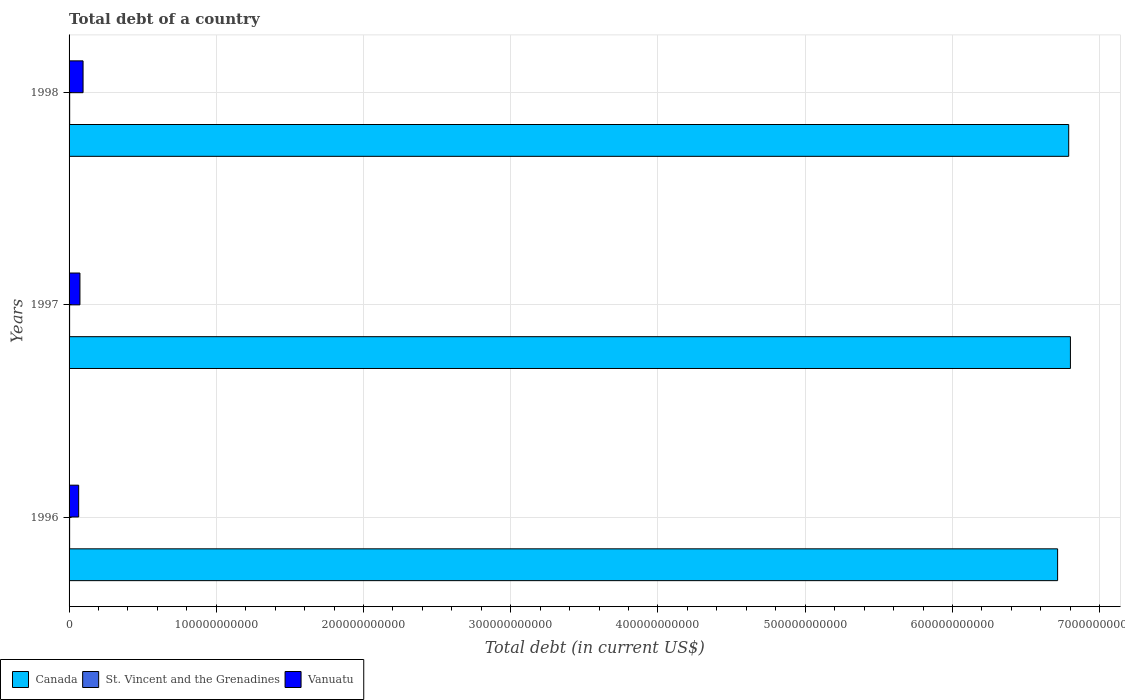How many different coloured bars are there?
Offer a very short reply. 3. How many groups of bars are there?
Offer a terse response. 3. Are the number of bars per tick equal to the number of legend labels?
Make the answer very short. Yes. What is the debt in Vanuatu in 1998?
Ensure brevity in your answer.  9.50e+09. Across all years, what is the maximum debt in Canada?
Give a very brief answer. 6.80e+11. Across all years, what is the minimum debt in Vanuatu?
Provide a short and direct response. 6.52e+09. In which year was the debt in Vanuatu maximum?
Offer a terse response. 1998. What is the total debt in St. Vincent and the Grenadines in the graph?
Keep it short and to the point. 1.15e+09. What is the difference between the debt in Canada in 1996 and that in 1997?
Make the answer very short. -8.71e+09. What is the difference between the debt in Canada in 1996 and the debt in St. Vincent and the Grenadines in 1998?
Offer a very short reply. 6.71e+11. What is the average debt in St. Vincent and the Grenadines per year?
Provide a succinct answer. 3.82e+08. In the year 1996, what is the difference between the debt in Vanuatu and debt in St. Vincent and the Grenadines?
Ensure brevity in your answer.  6.15e+09. In how many years, is the debt in St. Vincent and the Grenadines greater than 260000000000 US$?
Your answer should be very brief. 0. What is the ratio of the debt in Vanuatu in 1997 to that in 1998?
Your response must be concise. 0.78. Is the debt in Vanuatu in 1997 less than that in 1998?
Your response must be concise. Yes. Is the difference between the debt in Vanuatu in 1997 and 1998 greater than the difference between the debt in St. Vincent and the Grenadines in 1997 and 1998?
Provide a succinct answer. No. What is the difference between the highest and the second highest debt in Vanuatu?
Ensure brevity in your answer.  2.12e+09. What is the difference between the highest and the lowest debt in St. Vincent and the Grenadines?
Your answer should be very brief. 3.41e+07. What does the 2nd bar from the top in 1998 represents?
Provide a short and direct response. St. Vincent and the Grenadines. Is it the case that in every year, the sum of the debt in Canada and debt in Vanuatu is greater than the debt in St. Vincent and the Grenadines?
Your answer should be compact. Yes. How many bars are there?
Make the answer very short. 9. How many years are there in the graph?
Your answer should be compact. 3. What is the difference between two consecutive major ticks on the X-axis?
Offer a very short reply. 1.00e+11. Does the graph contain any zero values?
Your answer should be very brief. No. Does the graph contain grids?
Provide a succinct answer. Yes. Where does the legend appear in the graph?
Offer a very short reply. Bottom left. What is the title of the graph?
Your response must be concise. Total debt of a country. Does "Curacao" appear as one of the legend labels in the graph?
Make the answer very short. No. What is the label or title of the X-axis?
Offer a terse response. Total debt (in current US$). What is the label or title of the Y-axis?
Provide a short and direct response. Years. What is the Total debt (in current US$) in Canada in 1996?
Ensure brevity in your answer.  6.71e+11. What is the Total debt (in current US$) of St. Vincent and the Grenadines in 1996?
Provide a short and direct response. 3.72e+08. What is the Total debt (in current US$) of Vanuatu in 1996?
Your answer should be compact. 6.52e+09. What is the Total debt (in current US$) of Canada in 1997?
Offer a very short reply. 6.80e+11. What is the Total debt (in current US$) of St. Vincent and the Grenadines in 1997?
Give a very brief answer. 3.70e+08. What is the Total debt (in current US$) in Vanuatu in 1997?
Your response must be concise. 7.38e+09. What is the Total debt (in current US$) of Canada in 1998?
Keep it short and to the point. 6.79e+11. What is the Total debt (in current US$) of St. Vincent and the Grenadines in 1998?
Your answer should be very brief. 4.04e+08. What is the Total debt (in current US$) in Vanuatu in 1998?
Your answer should be very brief. 9.50e+09. Across all years, what is the maximum Total debt (in current US$) of Canada?
Give a very brief answer. 6.80e+11. Across all years, what is the maximum Total debt (in current US$) of St. Vincent and the Grenadines?
Your answer should be compact. 4.04e+08. Across all years, what is the maximum Total debt (in current US$) of Vanuatu?
Provide a succinct answer. 9.50e+09. Across all years, what is the minimum Total debt (in current US$) of Canada?
Keep it short and to the point. 6.71e+11. Across all years, what is the minimum Total debt (in current US$) in St. Vincent and the Grenadines?
Your answer should be compact. 3.70e+08. Across all years, what is the minimum Total debt (in current US$) in Vanuatu?
Provide a short and direct response. 6.52e+09. What is the total Total debt (in current US$) of Canada in the graph?
Offer a terse response. 2.03e+12. What is the total Total debt (in current US$) in St. Vincent and the Grenadines in the graph?
Your answer should be very brief. 1.15e+09. What is the total Total debt (in current US$) in Vanuatu in the graph?
Your answer should be compact. 2.34e+1. What is the difference between the Total debt (in current US$) in Canada in 1996 and that in 1997?
Your response must be concise. -8.71e+09. What is the difference between the Total debt (in current US$) of St. Vincent and the Grenadines in 1996 and that in 1997?
Make the answer very short. 2.60e+06. What is the difference between the Total debt (in current US$) of Vanuatu in 1996 and that in 1997?
Your answer should be very brief. -8.58e+08. What is the difference between the Total debt (in current US$) of Canada in 1996 and that in 1998?
Keep it short and to the point. -7.54e+09. What is the difference between the Total debt (in current US$) of St. Vincent and the Grenadines in 1996 and that in 1998?
Give a very brief answer. -3.15e+07. What is the difference between the Total debt (in current US$) of Vanuatu in 1996 and that in 1998?
Offer a very short reply. -2.98e+09. What is the difference between the Total debt (in current US$) in Canada in 1997 and that in 1998?
Your answer should be very brief. 1.16e+09. What is the difference between the Total debt (in current US$) in St. Vincent and the Grenadines in 1997 and that in 1998?
Keep it short and to the point. -3.41e+07. What is the difference between the Total debt (in current US$) of Vanuatu in 1997 and that in 1998?
Your answer should be very brief. -2.12e+09. What is the difference between the Total debt (in current US$) in Canada in 1996 and the Total debt (in current US$) in St. Vincent and the Grenadines in 1997?
Offer a very short reply. 6.71e+11. What is the difference between the Total debt (in current US$) in Canada in 1996 and the Total debt (in current US$) in Vanuatu in 1997?
Provide a succinct answer. 6.64e+11. What is the difference between the Total debt (in current US$) of St. Vincent and the Grenadines in 1996 and the Total debt (in current US$) of Vanuatu in 1997?
Your answer should be very brief. -7.01e+09. What is the difference between the Total debt (in current US$) in Canada in 1996 and the Total debt (in current US$) in St. Vincent and the Grenadines in 1998?
Your answer should be compact. 6.71e+11. What is the difference between the Total debt (in current US$) of Canada in 1996 and the Total debt (in current US$) of Vanuatu in 1998?
Your answer should be very brief. 6.62e+11. What is the difference between the Total debt (in current US$) of St. Vincent and the Grenadines in 1996 and the Total debt (in current US$) of Vanuatu in 1998?
Provide a short and direct response. -9.13e+09. What is the difference between the Total debt (in current US$) in Canada in 1997 and the Total debt (in current US$) in St. Vincent and the Grenadines in 1998?
Provide a short and direct response. 6.80e+11. What is the difference between the Total debt (in current US$) of Canada in 1997 and the Total debt (in current US$) of Vanuatu in 1998?
Make the answer very short. 6.71e+11. What is the difference between the Total debt (in current US$) of St. Vincent and the Grenadines in 1997 and the Total debt (in current US$) of Vanuatu in 1998?
Ensure brevity in your answer.  -9.13e+09. What is the average Total debt (in current US$) of Canada per year?
Offer a very short reply. 6.77e+11. What is the average Total debt (in current US$) of St. Vincent and the Grenadines per year?
Ensure brevity in your answer.  3.82e+08. What is the average Total debt (in current US$) of Vanuatu per year?
Keep it short and to the point. 7.80e+09. In the year 1996, what is the difference between the Total debt (in current US$) in Canada and Total debt (in current US$) in St. Vincent and the Grenadines?
Your response must be concise. 6.71e+11. In the year 1996, what is the difference between the Total debt (in current US$) of Canada and Total debt (in current US$) of Vanuatu?
Provide a succinct answer. 6.65e+11. In the year 1996, what is the difference between the Total debt (in current US$) in St. Vincent and the Grenadines and Total debt (in current US$) in Vanuatu?
Offer a terse response. -6.15e+09. In the year 1997, what is the difference between the Total debt (in current US$) in Canada and Total debt (in current US$) in St. Vincent and the Grenadines?
Make the answer very short. 6.80e+11. In the year 1997, what is the difference between the Total debt (in current US$) in Canada and Total debt (in current US$) in Vanuatu?
Provide a succinct answer. 6.73e+11. In the year 1997, what is the difference between the Total debt (in current US$) in St. Vincent and the Grenadines and Total debt (in current US$) in Vanuatu?
Your answer should be very brief. -7.01e+09. In the year 1998, what is the difference between the Total debt (in current US$) in Canada and Total debt (in current US$) in St. Vincent and the Grenadines?
Offer a terse response. 6.79e+11. In the year 1998, what is the difference between the Total debt (in current US$) in Canada and Total debt (in current US$) in Vanuatu?
Offer a very short reply. 6.69e+11. In the year 1998, what is the difference between the Total debt (in current US$) of St. Vincent and the Grenadines and Total debt (in current US$) of Vanuatu?
Provide a succinct answer. -9.10e+09. What is the ratio of the Total debt (in current US$) in Canada in 1996 to that in 1997?
Provide a succinct answer. 0.99. What is the ratio of the Total debt (in current US$) in Vanuatu in 1996 to that in 1997?
Give a very brief answer. 0.88. What is the ratio of the Total debt (in current US$) of Canada in 1996 to that in 1998?
Give a very brief answer. 0.99. What is the ratio of the Total debt (in current US$) of St. Vincent and the Grenadines in 1996 to that in 1998?
Provide a succinct answer. 0.92. What is the ratio of the Total debt (in current US$) of Vanuatu in 1996 to that in 1998?
Provide a short and direct response. 0.69. What is the ratio of the Total debt (in current US$) in Canada in 1997 to that in 1998?
Provide a succinct answer. 1. What is the ratio of the Total debt (in current US$) in St. Vincent and the Grenadines in 1997 to that in 1998?
Make the answer very short. 0.92. What is the ratio of the Total debt (in current US$) in Vanuatu in 1997 to that in 1998?
Make the answer very short. 0.78. What is the difference between the highest and the second highest Total debt (in current US$) of Canada?
Provide a short and direct response. 1.16e+09. What is the difference between the highest and the second highest Total debt (in current US$) in St. Vincent and the Grenadines?
Make the answer very short. 3.15e+07. What is the difference between the highest and the second highest Total debt (in current US$) of Vanuatu?
Your answer should be compact. 2.12e+09. What is the difference between the highest and the lowest Total debt (in current US$) in Canada?
Give a very brief answer. 8.71e+09. What is the difference between the highest and the lowest Total debt (in current US$) of St. Vincent and the Grenadines?
Ensure brevity in your answer.  3.41e+07. What is the difference between the highest and the lowest Total debt (in current US$) in Vanuatu?
Keep it short and to the point. 2.98e+09. 